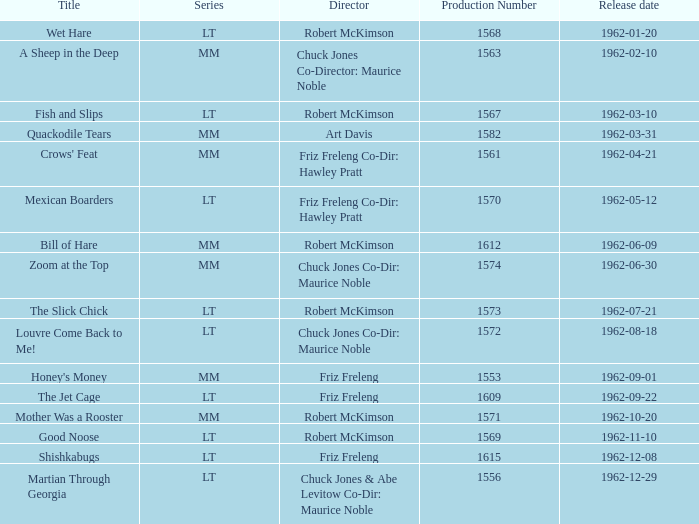What film has the title with production number 1553 and is directed by friz freleng? Honey's Money. 